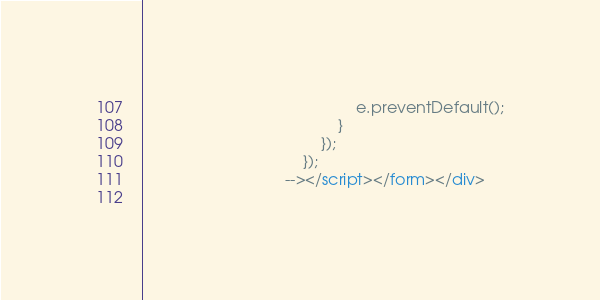<code> <loc_0><loc_0><loc_500><loc_500><_HTML_>                                                e.preventDefault();
                                            }
                                        });
                                    });
                                --></script></form></div>
        </code> 